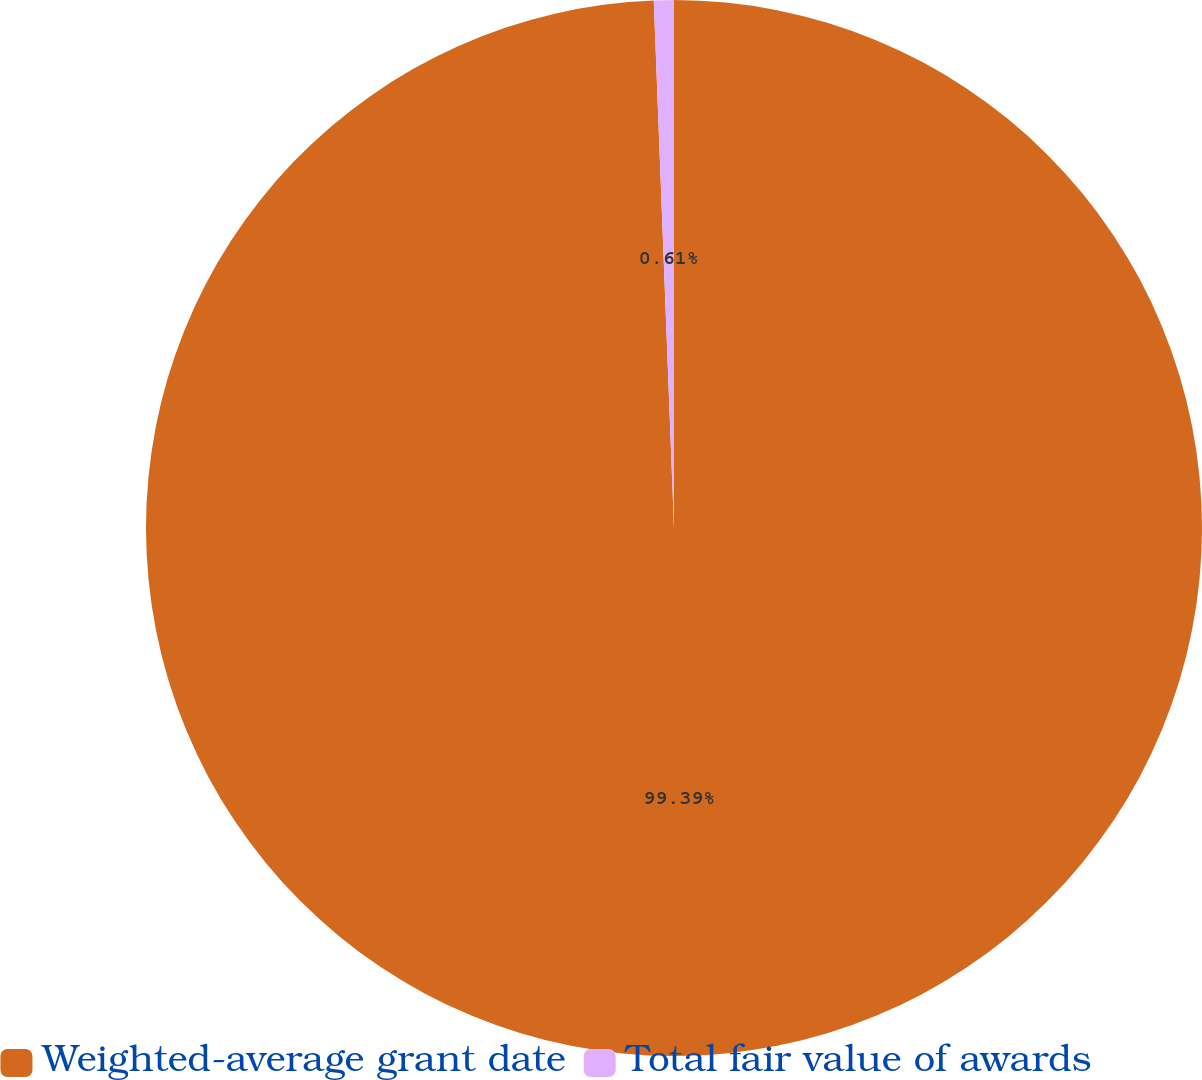Convert chart. <chart><loc_0><loc_0><loc_500><loc_500><pie_chart><fcel>Weighted-average grant date<fcel>Total fair value of awards<nl><fcel>99.39%<fcel>0.61%<nl></chart> 